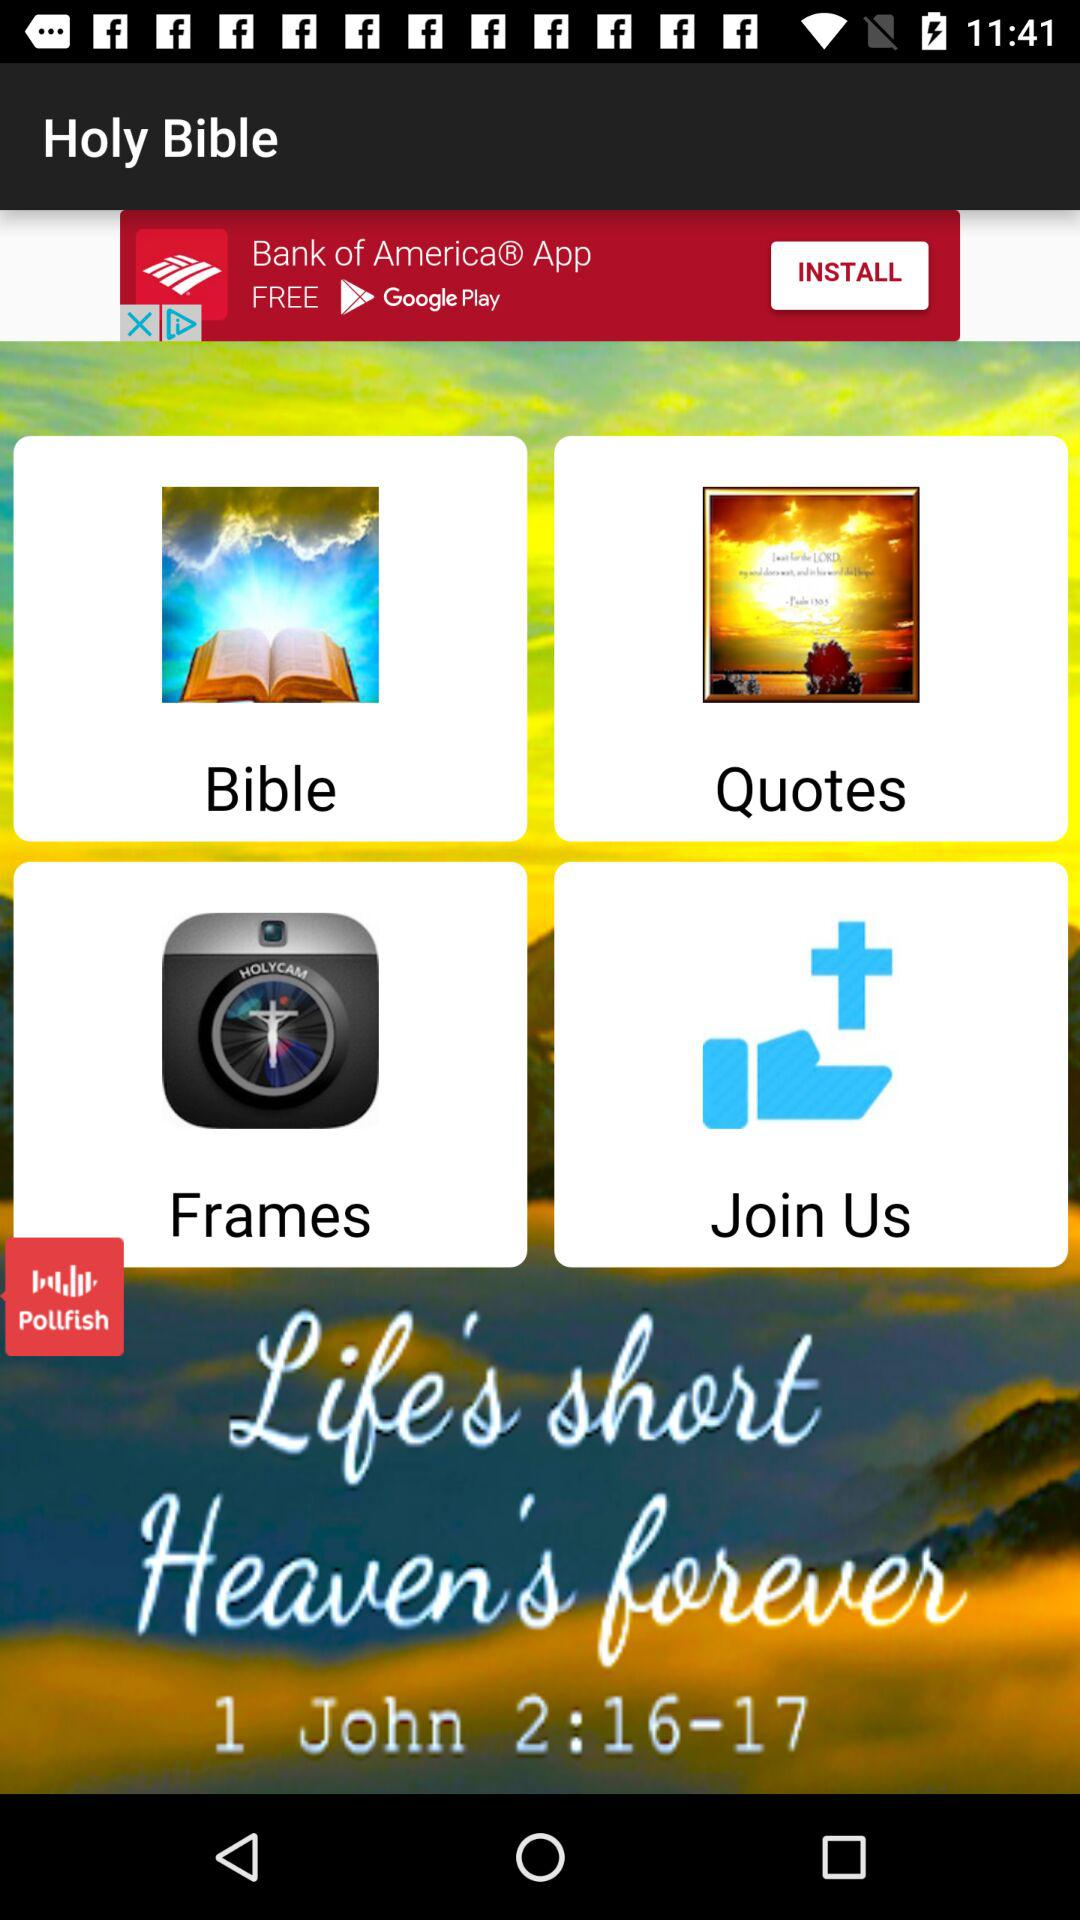What is the application name? The application name is "Holy Bible". 